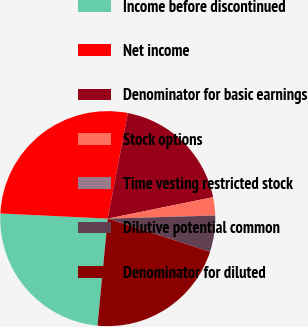Convert chart. <chart><loc_0><loc_0><loc_500><loc_500><pie_chart><fcel>Income before discontinued<fcel>Net income<fcel>Denominator for basic earnings<fcel>Stock options<fcel>Time vesting restricted stock<fcel>Dilutive potential common<fcel>Denominator for diluted<nl><fcel>24.25%<fcel>27.23%<fcel>18.8%<fcel>2.73%<fcel>0.01%<fcel>5.45%<fcel>21.53%<nl></chart> 